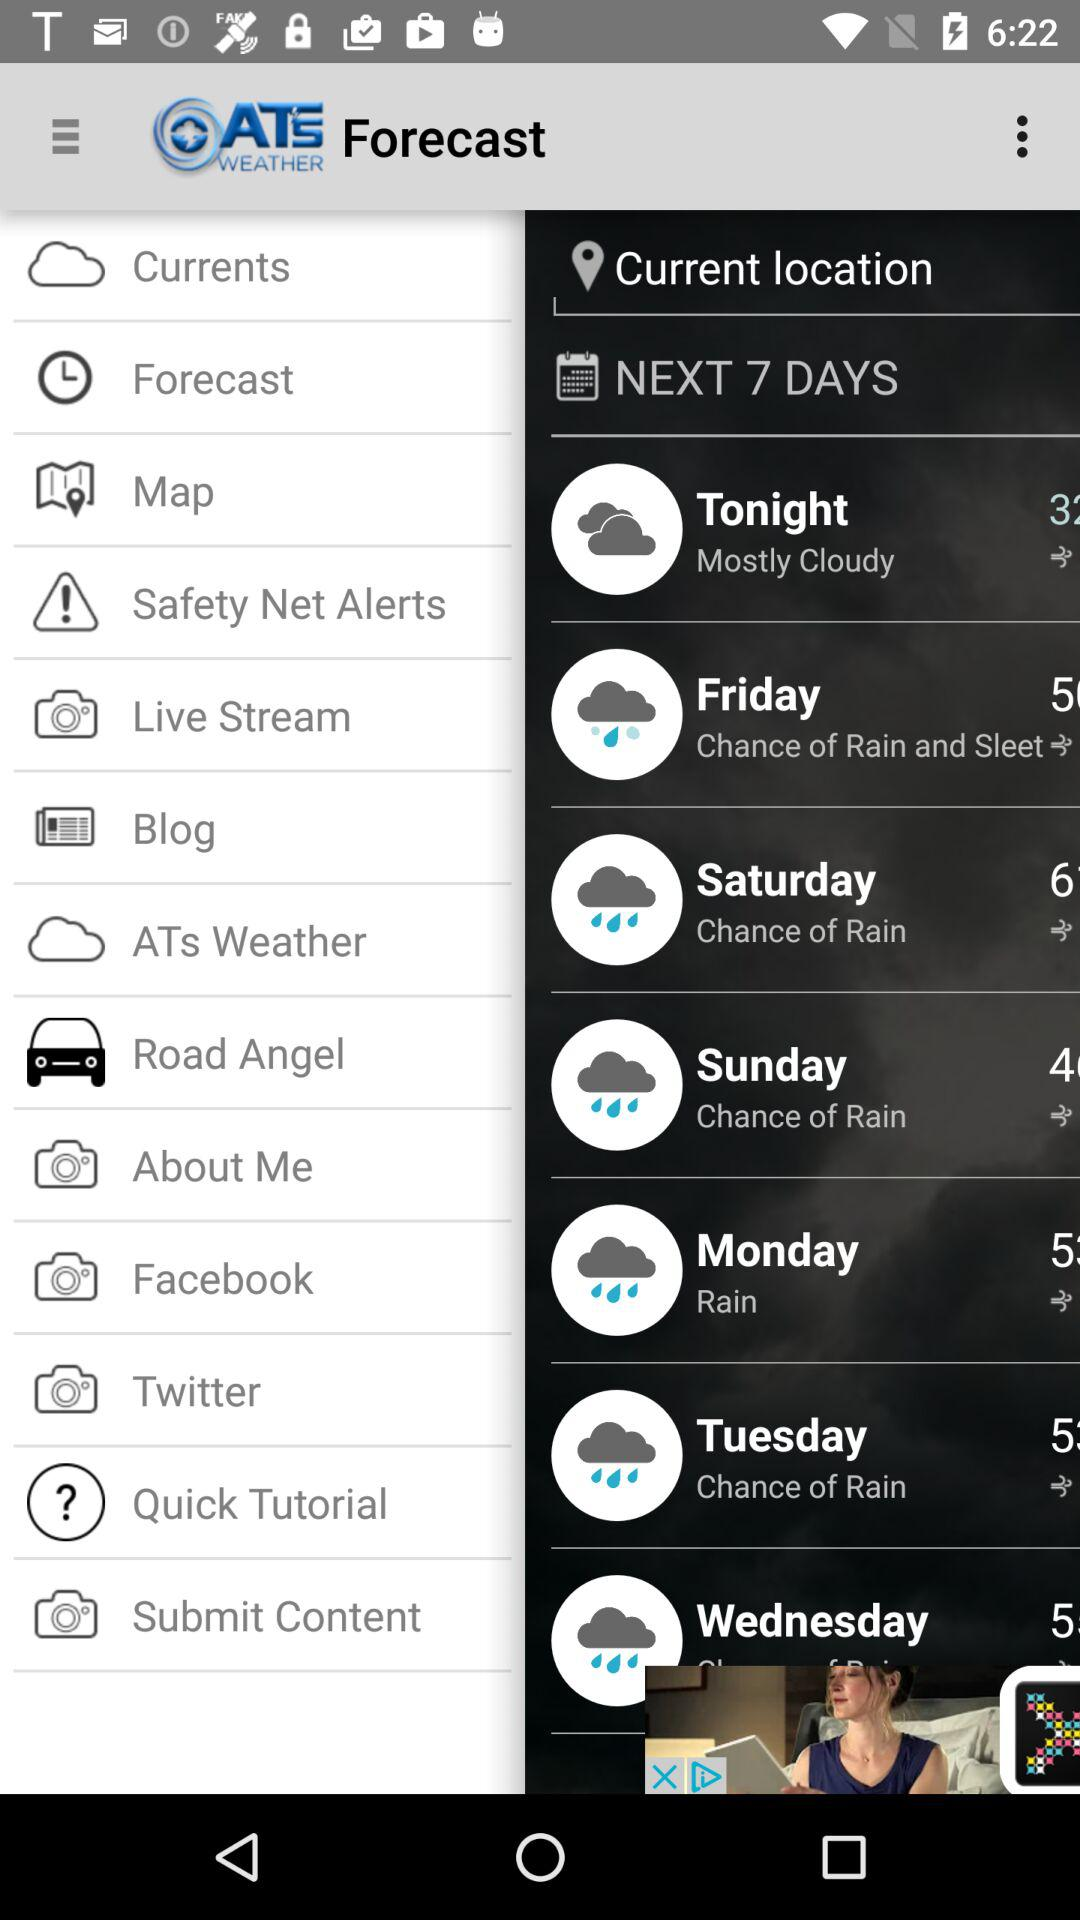On what day is it going to be "Mostly Cloudy"? It is going to be mostly cloudy tonight. 